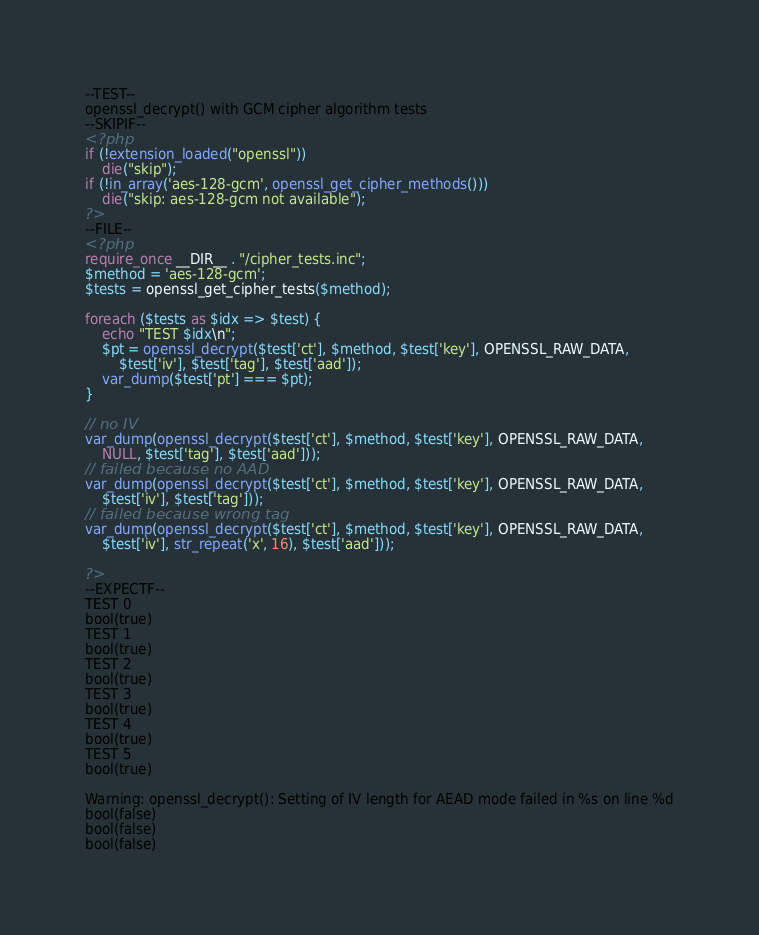<code> <loc_0><loc_0><loc_500><loc_500><_PHP_>--TEST--
openssl_decrypt() with GCM cipher algorithm tests
--SKIPIF--
<?php
if (!extension_loaded("openssl"))
	die("skip");
if (!in_array('aes-128-gcm', openssl_get_cipher_methods()))
	die("skip: aes-128-gcm not available");
?>
--FILE--
<?php
require_once __DIR__ . "/cipher_tests.inc";
$method = 'aes-128-gcm';
$tests = openssl_get_cipher_tests($method);

foreach ($tests as $idx => $test) {
	echo "TEST $idx\n";
	$pt = openssl_decrypt($test['ct'], $method, $test['key'], OPENSSL_RAW_DATA,
		$test['iv'], $test['tag'], $test['aad']);
	var_dump($test['pt'] === $pt);
}

// no IV
var_dump(openssl_decrypt($test['ct'], $method, $test['key'], OPENSSL_RAW_DATA,
	NULL, $test['tag'], $test['aad']));
// failed because no AAD
var_dump(openssl_decrypt($test['ct'], $method, $test['key'], OPENSSL_RAW_DATA,
	$test['iv'], $test['tag']));
// failed because wrong tag
var_dump(openssl_decrypt($test['ct'], $method, $test['key'], OPENSSL_RAW_DATA,
	$test['iv'], str_repeat('x', 16), $test['aad']));

?>
--EXPECTF--
TEST 0
bool(true)
TEST 1
bool(true)
TEST 2
bool(true)
TEST 3
bool(true)
TEST 4
bool(true)
TEST 5
bool(true)

Warning: openssl_decrypt(): Setting of IV length for AEAD mode failed in %s on line %d
bool(false)
bool(false)
bool(false)
</code> 